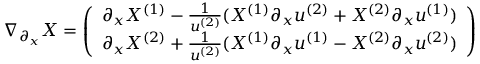Convert formula to latex. <formula><loc_0><loc_0><loc_500><loc_500>\nabla _ { \partial _ { x } } X = \left ( \begin{array} { l } { \partial _ { x } X ^ { ( 1 ) } - \frac { 1 } { u ^ { ( 2 ) } } ( X ^ { ( 1 ) } \partial _ { x } u ^ { ( 2 ) } + X ^ { ( 2 ) } \partial _ { x } u ^ { ( 1 ) } ) } \\ { \partial _ { x } X ^ { ( 2 ) } + \frac { 1 } { u ^ { ( 2 ) } } ( X ^ { ( 1 ) } \partial _ { x } u ^ { ( 1 ) } - X ^ { ( 2 ) } \partial _ { x } u ^ { ( 2 ) } ) } \end{array} \right )</formula> 